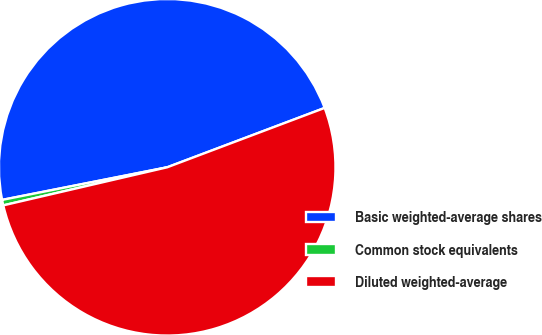Convert chart to OTSL. <chart><loc_0><loc_0><loc_500><loc_500><pie_chart><fcel>Basic weighted-average shares<fcel>Common stock equivalents<fcel>Diluted weighted-average<nl><fcel>47.37%<fcel>0.53%<fcel>52.11%<nl></chart> 